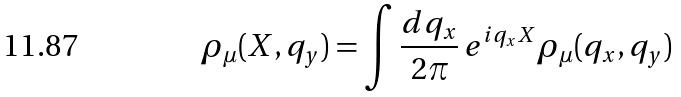<formula> <loc_0><loc_0><loc_500><loc_500>\rho _ { \mu } ( X , q _ { y } ) = \int \frac { d q _ { x } } { 2 \pi } \, e ^ { i q _ { x } X } \rho _ { \mu } ( q _ { x } , q _ { y } )</formula> 